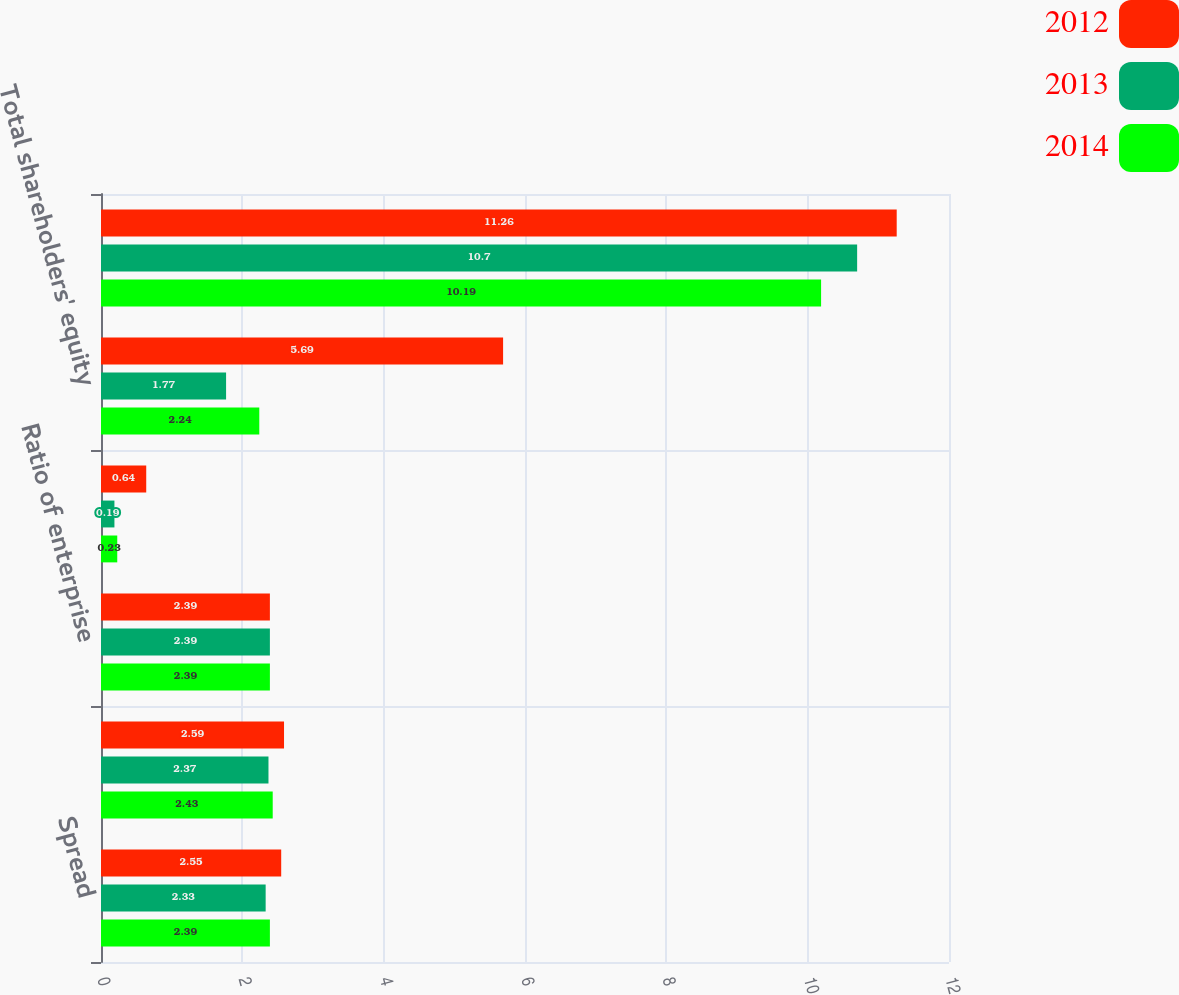Convert chart. <chart><loc_0><loc_0><loc_500><loc_500><stacked_bar_chart><ecel><fcel>Spread<fcel>Margin (net yield on<fcel>Ratio of enterprise<fcel>Total assets<fcel>Total shareholders' equity<fcel>Average total shareholders'<nl><fcel>2012<fcel>2.55<fcel>2.59<fcel>2.39<fcel>0.64<fcel>5.69<fcel>11.26<nl><fcel>2013<fcel>2.33<fcel>2.37<fcel>2.39<fcel>0.19<fcel>1.77<fcel>10.7<nl><fcel>2014<fcel>2.39<fcel>2.43<fcel>2.39<fcel>0.23<fcel>2.24<fcel>10.19<nl></chart> 